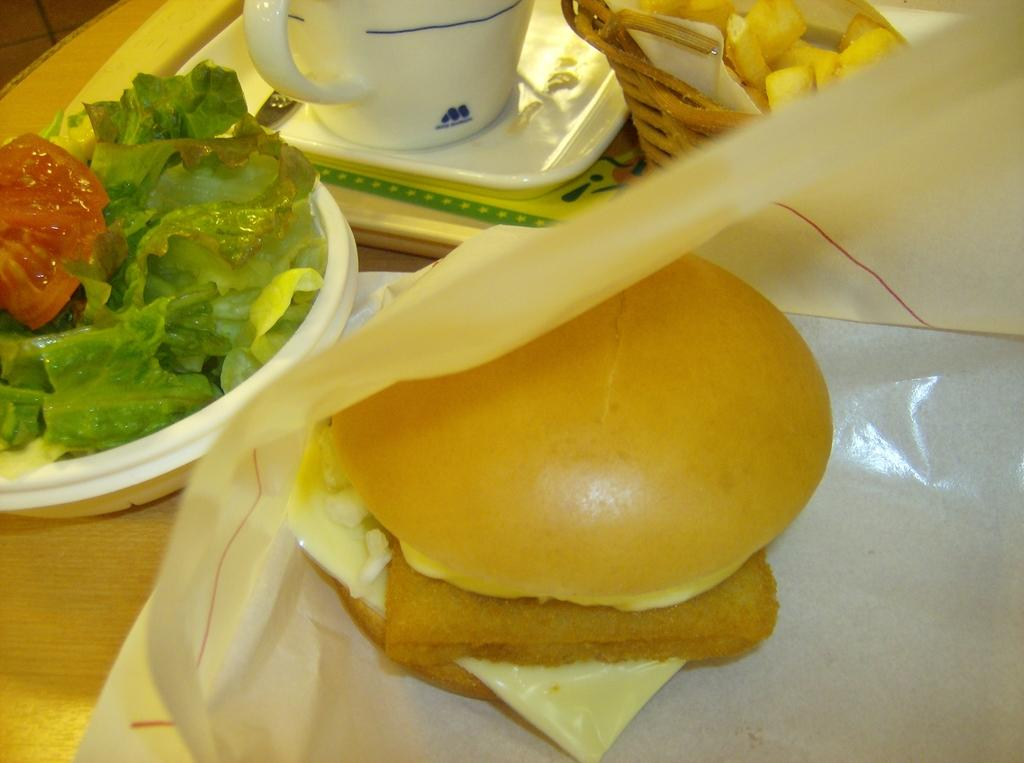What piece of furniture is present in the image? There is a table in the image. What is placed on the table? There is a cup and a spoon on the table. How are the cup and spoon arranged on the table? The cup and spoon are on a tray. What else can be seen on the table besides the cup and spoon? There are other food items arranged on the table. What type of glass is being used by the brother in the image? There is no brother present in the image, and no glass is visible. 